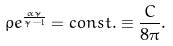Convert formula to latex. <formula><loc_0><loc_0><loc_500><loc_500>\rho e ^ { \frac { \alpha \tilde { \gamma } } { \tilde { \gamma } - 1 } } = c o n s t . \equiv \frac { C } { 8 \pi } .</formula> 